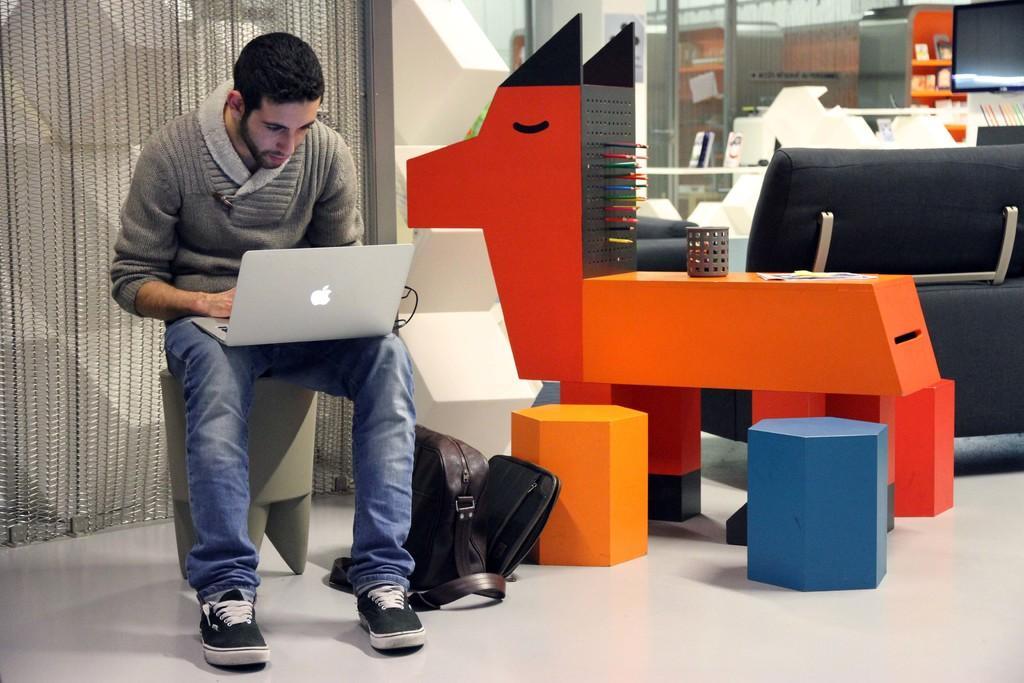How would you summarize this image in a sentence or two? This image is taken indoors. At the bottom of the image there is a floor. In the background there is a blind. On the right side of the image there is a couch on the floor. There is a table with a few things on it. There are a few objects. There is a television on the wall and there is a table with a few things on it. On the left side of the image a man is sitting on the stool and he is holding a laptop in his hands. In the middle of the image there is a bag on the floor and there are two stools on the floor. 